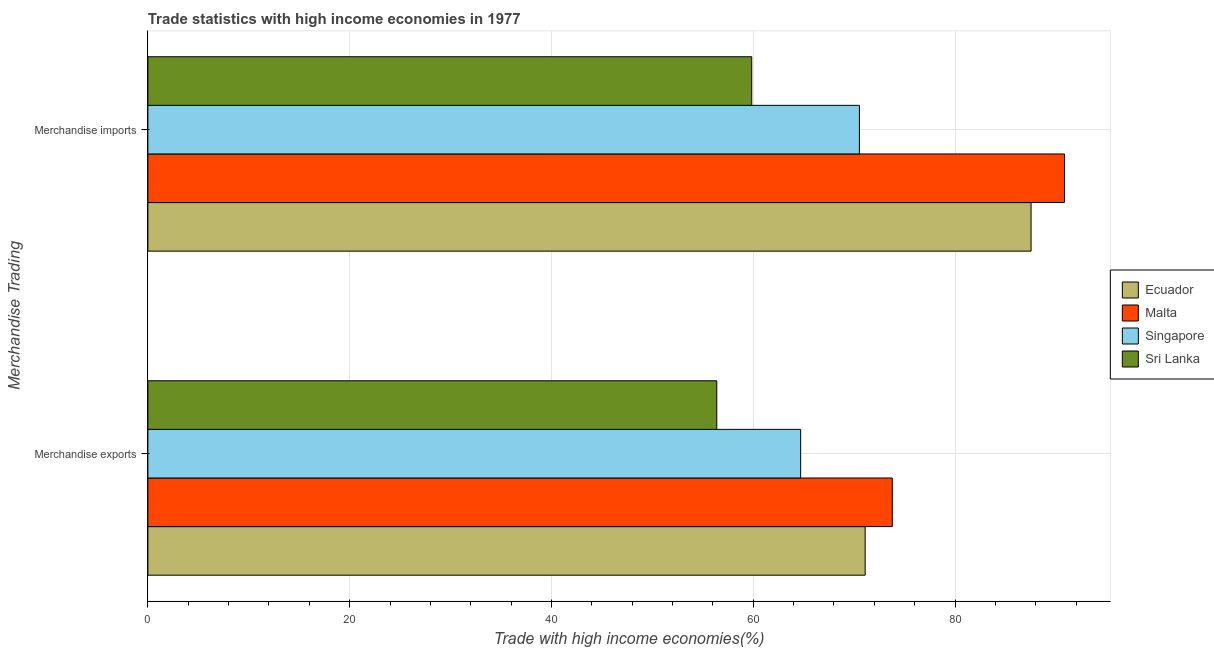How many groups of bars are there?
Offer a very short reply. 2. Are the number of bars per tick equal to the number of legend labels?
Ensure brevity in your answer.  Yes. Are the number of bars on each tick of the Y-axis equal?
Offer a very short reply. Yes. How many bars are there on the 2nd tick from the top?
Ensure brevity in your answer.  4. How many bars are there on the 1st tick from the bottom?
Offer a terse response. 4. What is the label of the 1st group of bars from the top?
Keep it short and to the point. Merchandise imports. What is the merchandise exports in Malta?
Provide a short and direct response. 73.78. Across all countries, what is the maximum merchandise imports?
Provide a succinct answer. 90.85. Across all countries, what is the minimum merchandise imports?
Your answer should be very brief. 59.85. In which country was the merchandise exports maximum?
Ensure brevity in your answer.  Malta. In which country was the merchandise exports minimum?
Offer a terse response. Sri Lanka. What is the total merchandise imports in the graph?
Ensure brevity in your answer.  308.75. What is the difference between the merchandise imports in Malta and that in Singapore?
Your answer should be compact. 20.33. What is the difference between the merchandise imports in Ecuador and the merchandise exports in Sri Lanka?
Your answer should be very brief. 31.15. What is the average merchandise exports per country?
Keep it short and to the point. 66.49. What is the difference between the merchandise imports and merchandise exports in Ecuador?
Give a very brief answer. 16.44. In how many countries, is the merchandise imports greater than 40 %?
Your response must be concise. 4. What is the ratio of the merchandise imports in Singapore to that in Sri Lanka?
Ensure brevity in your answer.  1.18. What does the 2nd bar from the top in Merchandise exports represents?
Your answer should be compact. Singapore. What does the 3rd bar from the bottom in Merchandise exports represents?
Provide a short and direct response. Singapore. How many bars are there?
Your answer should be compact. 8. How many countries are there in the graph?
Offer a very short reply. 4. Are the values on the major ticks of X-axis written in scientific E-notation?
Make the answer very short. No. How many legend labels are there?
Provide a succinct answer. 4. How are the legend labels stacked?
Offer a terse response. Vertical. What is the title of the graph?
Give a very brief answer. Trade statistics with high income economies in 1977. What is the label or title of the X-axis?
Your answer should be compact. Trade with high income economies(%). What is the label or title of the Y-axis?
Provide a succinct answer. Merchandise Trading. What is the Trade with high income economies(%) of Ecuador in Merchandise exports?
Ensure brevity in your answer.  71.09. What is the Trade with high income economies(%) in Malta in Merchandise exports?
Keep it short and to the point. 73.78. What is the Trade with high income economies(%) of Singapore in Merchandise exports?
Your answer should be very brief. 64.7. What is the Trade with high income economies(%) of Sri Lanka in Merchandise exports?
Offer a terse response. 56.39. What is the Trade with high income economies(%) in Ecuador in Merchandise imports?
Make the answer very short. 87.53. What is the Trade with high income economies(%) in Malta in Merchandise imports?
Provide a short and direct response. 90.85. What is the Trade with high income economies(%) in Singapore in Merchandise imports?
Your response must be concise. 70.52. What is the Trade with high income economies(%) of Sri Lanka in Merchandise imports?
Keep it short and to the point. 59.85. Across all Merchandise Trading, what is the maximum Trade with high income economies(%) in Ecuador?
Provide a short and direct response. 87.53. Across all Merchandise Trading, what is the maximum Trade with high income economies(%) of Malta?
Provide a succinct answer. 90.85. Across all Merchandise Trading, what is the maximum Trade with high income economies(%) of Singapore?
Your response must be concise. 70.52. Across all Merchandise Trading, what is the maximum Trade with high income economies(%) in Sri Lanka?
Keep it short and to the point. 59.85. Across all Merchandise Trading, what is the minimum Trade with high income economies(%) in Ecuador?
Keep it short and to the point. 71.09. Across all Merchandise Trading, what is the minimum Trade with high income economies(%) in Malta?
Offer a terse response. 73.78. Across all Merchandise Trading, what is the minimum Trade with high income economies(%) of Singapore?
Make the answer very short. 64.7. Across all Merchandise Trading, what is the minimum Trade with high income economies(%) of Sri Lanka?
Ensure brevity in your answer.  56.39. What is the total Trade with high income economies(%) in Ecuador in the graph?
Make the answer very short. 158.63. What is the total Trade with high income economies(%) of Malta in the graph?
Your answer should be compact. 164.63. What is the total Trade with high income economies(%) of Singapore in the graph?
Offer a terse response. 135.22. What is the total Trade with high income economies(%) in Sri Lanka in the graph?
Make the answer very short. 116.23. What is the difference between the Trade with high income economies(%) in Ecuador in Merchandise exports and that in Merchandise imports?
Your answer should be compact. -16.44. What is the difference between the Trade with high income economies(%) of Malta in Merchandise exports and that in Merchandise imports?
Provide a succinct answer. -17.07. What is the difference between the Trade with high income economies(%) in Singapore in Merchandise exports and that in Merchandise imports?
Make the answer very short. -5.82. What is the difference between the Trade with high income economies(%) in Sri Lanka in Merchandise exports and that in Merchandise imports?
Make the answer very short. -3.46. What is the difference between the Trade with high income economies(%) of Ecuador in Merchandise exports and the Trade with high income economies(%) of Malta in Merchandise imports?
Make the answer very short. -19.76. What is the difference between the Trade with high income economies(%) in Ecuador in Merchandise exports and the Trade with high income economies(%) in Singapore in Merchandise imports?
Give a very brief answer. 0.57. What is the difference between the Trade with high income economies(%) of Ecuador in Merchandise exports and the Trade with high income economies(%) of Sri Lanka in Merchandise imports?
Make the answer very short. 11.24. What is the difference between the Trade with high income economies(%) in Malta in Merchandise exports and the Trade with high income economies(%) in Singapore in Merchandise imports?
Your response must be concise. 3.26. What is the difference between the Trade with high income economies(%) of Malta in Merchandise exports and the Trade with high income economies(%) of Sri Lanka in Merchandise imports?
Make the answer very short. 13.93. What is the difference between the Trade with high income economies(%) in Singapore in Merchandise exports and the Trade with high income economies(%) in Sri Lanka in Merchandise imports?
Provide a succinct answer. 4.85. What is the average Trade with high income economies(%) of Ecuador per Merchandise Trading?
Provide a succinct answer. 79.31. What is the average Trade with high income economies(%) in Malta per Merchandise Trading?
Your response must be concise. 82.31. What is the average Trade with high income economies(%) of Singapore per Merchandise Trading?
Make the answer very short. 67.61. What is the average Trade with high income economies(%) of Sri Lanka per Merchandise Trading?
Ensure brevity in your answer.  58.12. What is the difference between the Trade with high income economies(%) in Ecuador and Trade with high income economies(%) in Malta in Merchandise exports?
Offer a very short reply. -2.69. What is the difference between the Trade with high income economies(%) of Ecuador and Trade with high income economies(%) of Singapore in Merchandise exports?
Offer a terse response. 6.39. What is the difference between the Trade with high income economies(%) of Ecuador and Trade with high income economies(%) of Sri Lanka in Merchandise exports?
Offer a terse response. 14.71. What is the difference between the Trade with high income economies(%) of Malta and Trade with high income economies(%) of Singapore in Merchandise exports?
Offer a very short reply. 9.08. What is the difference between the Trade with high income economies(%) in Malta and Trade with high income economies(%) in Sri Lanka in Merchandise exports?
Give a very brief answer. 17.4. What is the difference between the Trade with high income economies(%) of Singapore and Trade with high income economies(%) of Sri Lanka in Merchandise exports?
Keep it short and to the point. 8.31. What is the difference between the Trade with high income economies(%) of Ecuador and Trade with high income economies(%) of Malta in Merchandise imports?
Keep it short and to the point. -3.31. What is the difference between the Trade with high income economies(%) of Ecuador and Trade with high income economies(%) of Singapore in Merchandise imports?
Offer a very short reply. 17.02. What is the difference between the Trade with high income economies(%) in Ecuador and Trade with high income economies(%) in Sri Lanka in Merchandise imports?
Provide a short and direct response. 27.69. What is the difference between the Trade with high income economies(%) in Malta and Trade with high income economies(%) in Singapore in Merchandise imports?
Make the answer very short. 20.33. What is the difference between the Trade with high income economies(%) of Malta and Trade with high income economies(%) of Sri Lanka in Merchandise imports?
Give a very brief answer. 31. What is the difference between the Trade with high income economies(%) of Singapore and Trade with high income economies(%) of Sri Lanka in Merchandise imports?
Offer a terse response. 10.67. What is the ratio of the Trade with high income economies(%) in Ecuador in Merchandise exports to that in Merchandise imports?
Make the answer very short. 0.81. What is the ratio of the Trade with high income economies(%) of Malta in Merchandise exports to that in Merchandise imports?
Provide a succinct answer. 0.81. What is the ratio of the Trade with high income economies(%) of Singapore in Merchandise exports to that in Merchandise imports?
Offer a very short reply. 0.92. What is the ratio of the Trade with high income economies(%) in Sri Lanka in Merchandise exports to that in Merchandise imports?
Offer a very short reply. 0.94. What is the difference between the highest and the second highest Trade with high income economies(%) in Ecuador?
Provide a short and direct response. 16.44. What is the difference between the highest and the second highest Trade with high income economies(%) in Malta?
Give a very brief answer. 17.07. What is the difference between the highest and the second highest Trade with high income economies(%) in Singapore?
Give a very brief answer. 5.82. What is the difference between the highest and the second highest Trade with high income economies(%) of Sri Lanka?
Your response must be concise. 3.46. What is the difference between the highest and the lowest Trade with high income economies(%) of Ecuador?
Give a very brief answer. 16.44. What is the difference between the highest and the lowest Trade with high income economies(%) in Malta?
Your answer should be compact. 17.07. What is the difference between the highest and the lowest Trade with high income economies(%) in Singapore?
Your response must be concise. 5.82. What is the difference between the highest and the lowest Trade with high income economies(%) of Sri Lanka?
Provide a succinct answer. 3.46. 